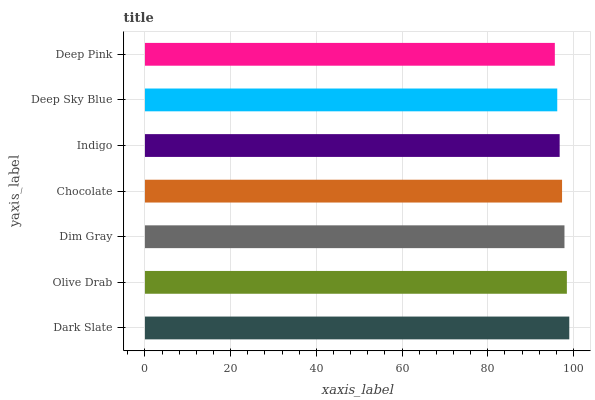Is Deep Pink the minimum?
Answer yes or no. Yes. Is Dark Slate the maximum?
Answer yes or no. Yes. Is Olive Drab the minimum?
Answer yes or no. No. Is Olive Drab the maximum?
Answer yes or no. No. Is Dark Slate greater than Olive Drab?
Answer yes or no. Yes. Is Olive Drab less than Dark Slate?
Answer yes or no. Yes. Is Olive Drab greater than Dark Slate?
Answer yes or no. No. Is Dark Slate less than Olive Drab?
Answer yes or no. No. Is Chocolate the high median?
Answer yes or no. Yes. Is Chocolate the low median?
Answer yes or no. Yes. Is Dark Slate the high median?
Answer yes or no. No. Is Indigo the low median?
Answer yes or no. No. 